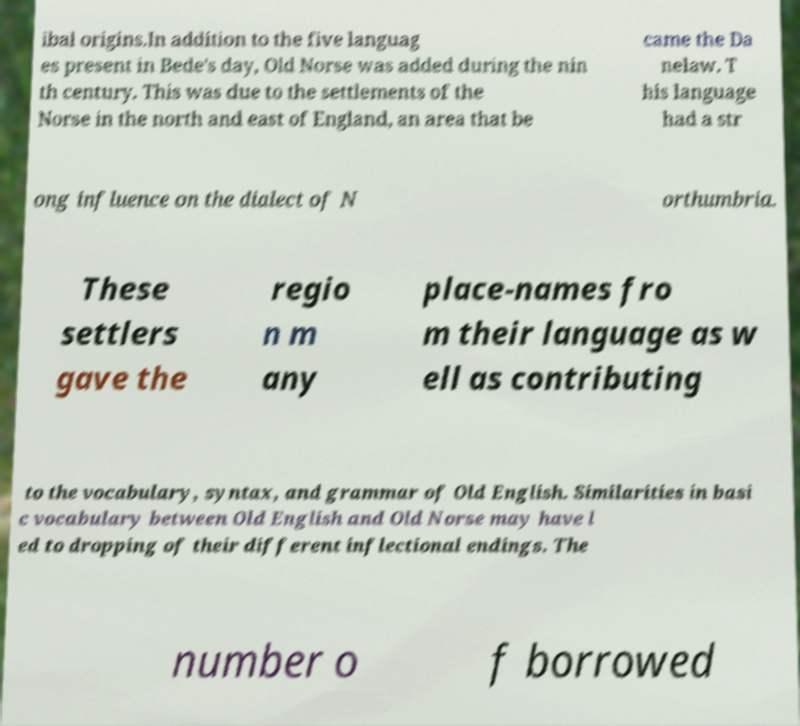Could you assist in decoding the text presented in this image and type it out clearly? ibal origins.In addition to the five languag es present in Bede's day, Old Norse was added during the nin th century. This was due to the settlements of the Norse in the north and east of England, an area that be came the Da nelaw. T his language had a str ong influence on the dialect of N orthumbria. These settlers gave the regio n m any place-names fro m their language as w ell as contributing to the vocabulary, syntax, and grammar of Old English. Similarities in basi c vocabulary between Old English and Old Norse may have l ed to dropping of their different inflectional endings. The number o f borrowed 